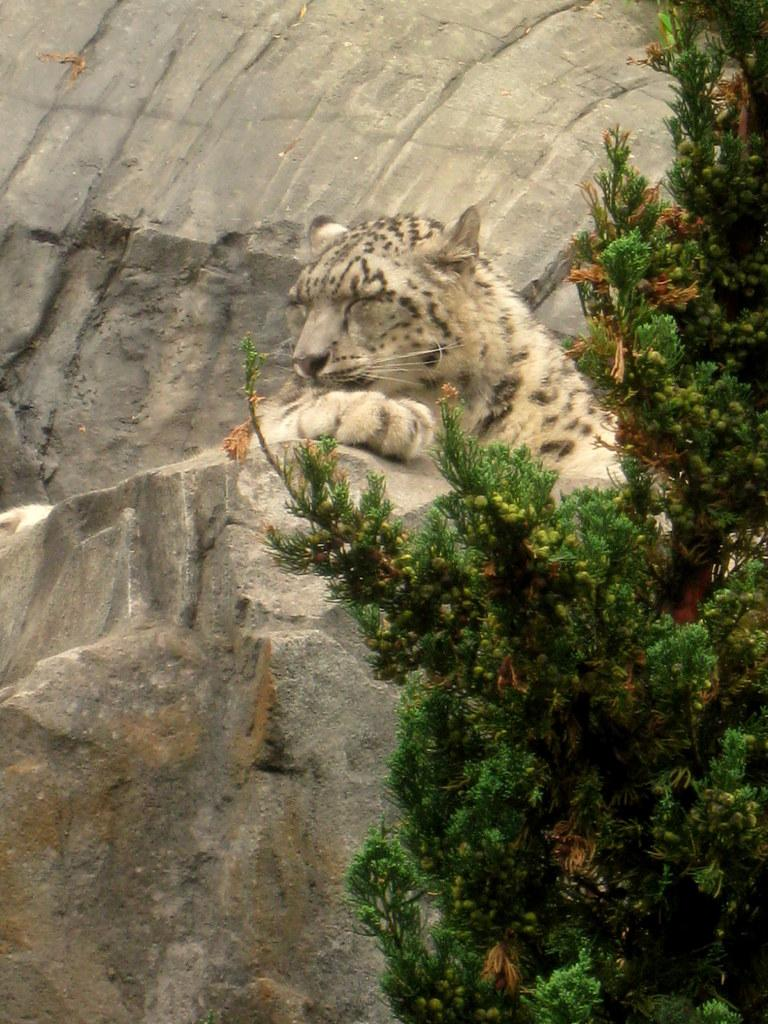What animal is the main subject of the image? There is a leopard in the image. Where is the leopard located in the image? The leopard is sitting on a rock. What other natural elements can be seen in the image? There is a tree in the image. What type of dinner is the leopard preparing in the image? There is no dinner preparation or any indication of food in the image; it simply features a leopard sitting on a rock. 